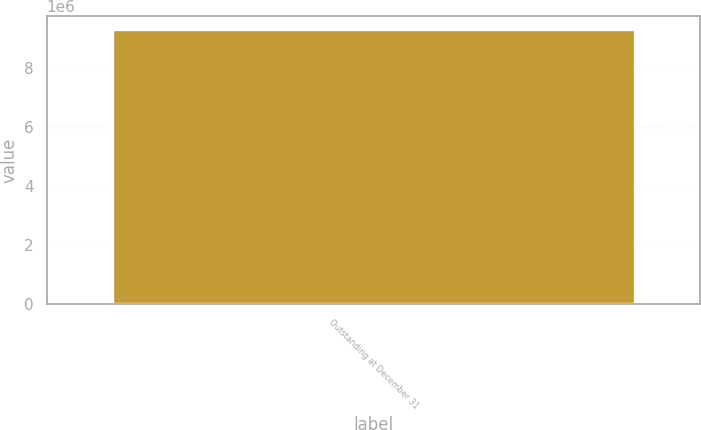Convert chart to OTSL. <chart><loc_0><loc_0><loc_500><loc_500><bar_chart><fcel>Outstanding at December 31<nl><fcel>9.31964e+06<nl></chart> 